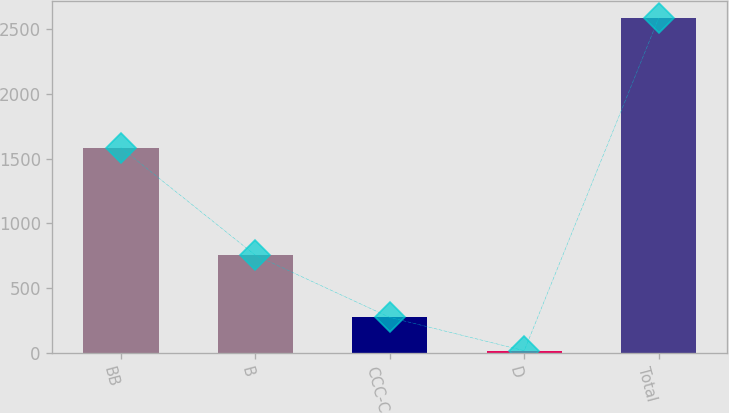Convert chart to OTSL. <chart><loc_0><loc_0><loc_500><loc_500><bar_chart><fcel>BB<fcel>B<fcel>CCC-C<fcel>D<fcel>Total<nl><fcel>1585<fcel>754<fcel>273.1<fcel>16<fcel>2587<nl></chart> 